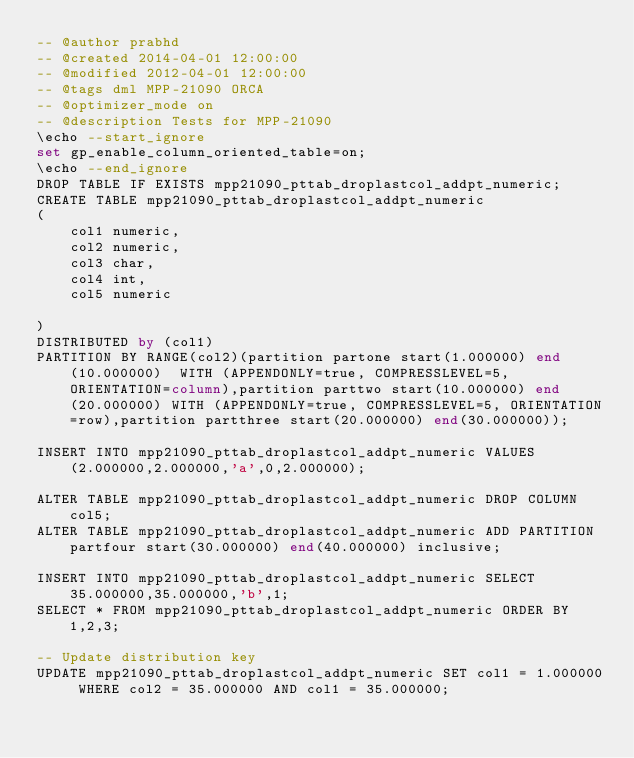<code> <loc_0><loc_0><loc_500><loc_500><_SQL_>-- @author prabhd 
-- @created 2014-04-01 12:00:00
-- @modified 2012-04-01 12:00:00
-- @tags dml MPP-21090 ORCA
-- @optimizer_mode on	
-- @description Tests for MPP-21090
\echo --start_ignore
set gp_enable_column_oriented_table=on;
\echo --end_ignore
DROP TABLE IF EXISTS mpp21090_pttab_droplastcol_addpt_numeric;
CREATE TABLE mpp21090_pttab_droplastcol_addpt_numeric
(
    col1 numeric,
    col2 numeric,
    col3 char,
    col4 int,
    col5 numeric
    
) 
DISTRIBUTED by (col1)
PARTITION BY RANGE(col2)(partition partone start(1.000000) end(10.000000)  WITH (APPENDONLY=true, COMPRESSLEVEL=5, ORIENTATION=column),partition parttwo start(10.000000) end(20.000000) WITH (APPENDONLY=true, COMPRESSLEVEL=5, ORIENTATION=row),partition partthree start(20.000000) end(30.000000));

INSERT INTO mpp21090_pttab_droplastcol_addpt_numeric VALUES(2.000000,2.000000,'a',0,2.000000);

ALTER TABLE mpp21090_pttab_droplastcol_addpt_numeric DROP COLUMN col5;
ALTER TABLE mpp21090_pttab_droplastcol_addpt_numeric ADD PARTITION partfour start(30.000000) end(40.000000) inclusive;

INSERT INTO mpp21090_pttab_droplastcol_addpt_numeric SELECT 35.000000,35.000000,'b',1;
SELECT * FROM mpp21090_pttab_droplastcol_addpt_numeric ORDER BY 1,2,3;

-- Update distribution key
UPDATE mpp21090_pttab_droplastcol_addpt_numeric SET col1 = 1.000000 WHERE col2 = 35.000000 AND col1 = 35.000000;</code> 